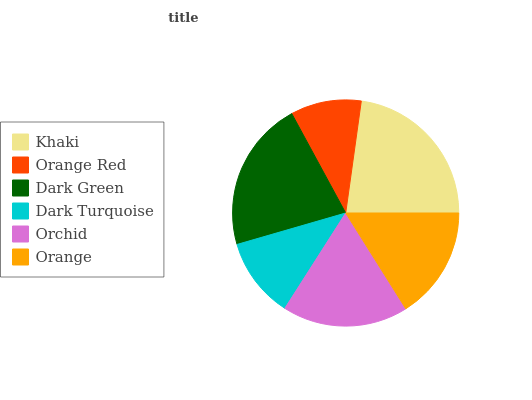Is Orange Red the minimum?
Answer yes or no. Yes. Is Khaki the maximum?
Answer yes or no. Yes. Is Dark Green the minimum?
Answer yes or no. No. Is Dark Green the maximum?
Answer yes or no. No. Is Dark Green greater than Orange Red?
Answer yes or no. Yes. Is Orange Red less than Dark Green?
Answer yes or no. Yes. Is Orange Red greater than Dark Green?
Answer yes or no. No. Is Dark Green less than Orange Red?
Answer yes or no. No. Is Orchid the high median?
Answer yes or no. Yes. Is Orange the low median?
Answer yes or no. Yes. Is Khaki the high median?
Answer yes or no. No. Is Orange Red the low median?
Answer yes or no. No. 